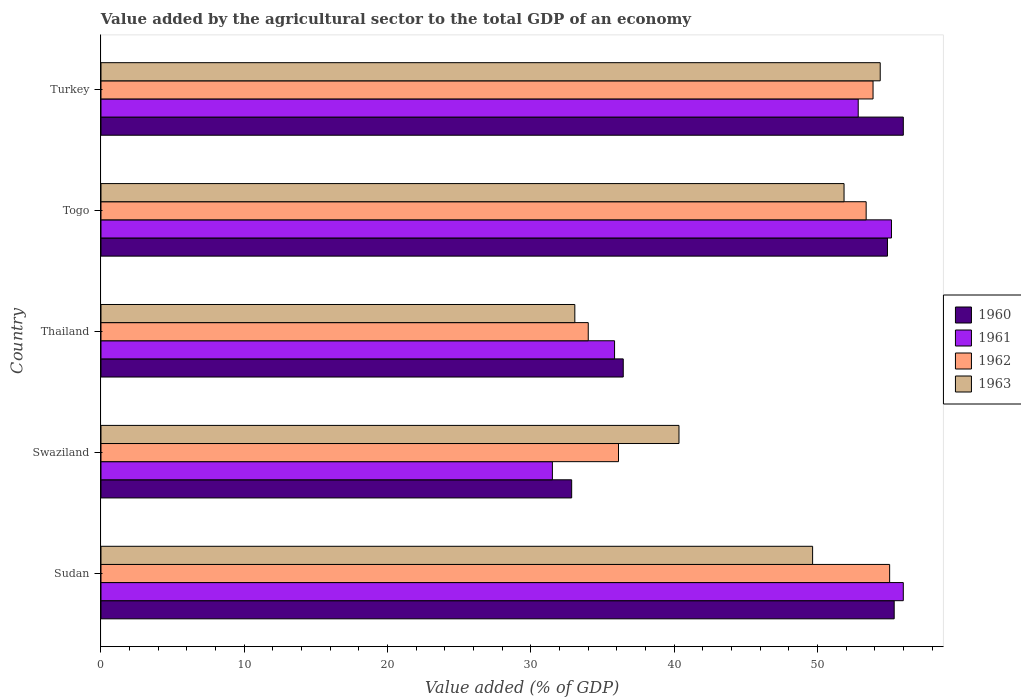How many different coloured bars are there?
Your answer should be compact. 4. How many bars are there on the 1st tick from the top?
Make the answer very short. 4. What is the label of the 5th group of bars from the top?
Provide a succinct answer. Sudan. What is the value added by the agricultural sector to the total GDP in 1960 in Turkey?
Offer a very short reply. 55.99. Across all countries, what is the maximum value added by the agricultural sector to the total GDP in 1960?
Provide a succinct answer. 55.99. Across all countries, what is the minimum value added by the agricultural sector to the total GDP in 1960?
Make the answer very short. 32.84. In which country was the value added by the agricultural sector to the total GDP in 1960 maximum?
Give a very brief answer. Turkey. In which country was the value added by the agricultural sector to the total GDP in 1963 minimum?
Ensure brevity in your answer.  Thailand. What is the total value added by the agricultural sector to the total GDP in 1963 in the graph?
Your answer should be compact. 229.29. What is the difference between the value added by the agricultural sector to the total GDP in 1962 in Swaziland and that in Thailand?
Offer a very short reply. 2.11. What is the difference between the value added by the agricultural sector to the total GDP in 1962 in Swaziland and the value added by the agricultural sector to the total GDP in 1963 in Thailand?
Give a very brief answer. 3.05. What is the average value added by the agricultural sector to the total GDP in 1963 per country?
Offer a very short reply. 45.86. What is the difference between the value added by the agricultural sector to the total GDP in 1963 and value added by the agricultural sector to the total GDP in 1960 in Swaziland?
Ensure brevity in your answer.  7.49. In how many countries, is the value added by the agricultural sector to the total GDP in 1960 greater than 22 %?
Keep it short and to the point. 5. What is the ratio of the value added by the agricultural sector to the total GDP in 1960 in Sudan to that in Turkey?
Your response must be concise. 0.99. Is the value added by the agricultural sector to the total GDP in 1962 in Sudan less than that in Togo?
Make the answer very short. No. What is the difference between the highest and the second highest value added by the agricultural sector to the total GDP in 1962?
Your response must be concise. 1.16. What is the difference between the highest and the lowest value added by the agricultural sector to the total GDP in 1960?
Offer a very short reply. 23.14. In how many countries, is the value added by the agricultural sector to the total GDP in 1963 greater than the average value added by the agricultural sector to the total GDP in 1963 taken over all countries?
Your answer should be very brief. 3. Is the sum of the value added by the agricultural sector to the total GDP in 1960 in Swaziland and Togo greater than the maximum value added by the agricultural sector to the total GDP in 1962 across all countries?
Your response must be concise. Yes. Is it the case that in every country, the sum of the value added by the agricultural sector to the total GDP in 1961 and value added by the agricultural sector to the total GDP in 1963 is greater than the sum of value added by the agricultural sector to the total GDP in 1962 and value added by the agricultural sector to the total GDP in 1960?
Provide a short and direct response. No. What does the 3rd bar from the top in Sudan represents?
Provide a short and direct response. 1961. Is it the case that in every country, the sum of the value added by the agricultural sector to the total GDP in 1960 and value added by the agricultural sector to the total GDP in 1962 is greater than the value added by the agricultural sector to the total GDP in 1963?
Offer a very short reply. Yes. Are all the bars in the graph horizontal?
Offer a terse response. Yes. What is the difference between two consecutive major ticks on the X-axis?
Give a very brief answer. 10. Does the graph contain any zero values?
Provide a succinct answer. No. Where does the legend appear in the graph?
Your answer should be compact. Center right. How many legend labels are there?
Provide a short and direct response. 4. What is the title of the graph?
Give a very brief answer. Value added by the agricultural sector to the total GDP of an economy. Does "1997" appear as one of the legend labels in the graph?
Your answer should be compact. No. What is the label or title of the X-axis?
Offer a very short reply. Value added (% of GDP). What is the Value added (% of GDP) of 1960 in Sudan?
Make the answer very short. 55.35. What is the Value added (% of GDP) of 1961 in Sudan?
Offer a very short reply. 55.99. What is the Value added (% of GDP) of 1962 in Sudan?
Give a very brief answer. 55.03. What is the Value added (% of GDP) of 1963 in Sudan?
Provide a succinct answer. 49.66. What is the Value added (% of GDP) of 1960 in Swaziland?
Provide a short and direct response. 32.84. What is the Value added (% of GDP) of 1961 in Swaziland?
Provide a short and direct response. 31.5. What is the Value added (% of GDP) in 1962 in Swaziland?
Offer a terse response. 36.11. What is the Value added (% of GDP) in 1963 in Swaziland?
Provide a succinct answer. 40.33. What is the Value added (% of GDP) in 1960 in Thailand?
Offer a terse response. 36.44. What is the Value added (% of GDP) of 1961 in Thailand?
Provide a succinct answer. 35.84. What is the Value added (% of GDP) in 1962 in Thailand?
Offer a terse response. 34. What is the Value added (% of GDP) in 1963 in Thailand?
Provide a succinct answer. 33.07. What is the Value added (% of GDP) in 1960 in Togo?
Ensure brevity in your answer.  54.88. What is the Value added (% of GDP) in 1961 in Togo?
Make the answer very short. 55.16. What is the Value added (% of GDP) in 1962 in Togo?
Ensure brevity in your answer.  53.4. What is the Value added (% of GDP) in 1963 in Togo?
Your answer should be very brief. 51.85. What is the Value added (% of GDP) of 1960 in Turkey?
Make the answer very short. 55.99. What is the Value added (% of GDP) of 1961 in Turkey?
Your response must be concise. 52.84. What is the Value added (% of GDP) in 1962 in Turkey?
Offer a very short reply. 53.88. What is the Value added (% of GDP) of 1963 in Turkey?
Ensure brevity in your answer.  54.38. Across all countries, what is the maximum Value added (% of GDP) of 1960?
Offer a terse response. 55.99. Across all countries, what is the maximum Value added (% of GDP) of 1961?
Your answer should be very brief. 55.99. Across all countries, what is the maximum Value added (% of GDP) of 1962?
Offer a very short reply. 55.03. Across all countries, what is the maximum Value added (% of GDP) in 1963?
Provide a succinct answer. 54.38. Across all countries, what is the minimum Value added (% of GDP) in 1960?
Provide a short and direct response. 32.84. Across all countries, what is the minimum Value added (% of GDP) in 1961?
Your answer should be very brief. 31.5. Across all countries, what is the minimum Value added (% of GDP) of 1962?
Ensure brevity in your answer.  34. Across all countries, what is the minimum Value added (% of GDP) of 1963?
Your response must be concise. 33.07. What is the total Value added (% of GDP) in 1960 in the graph?
Make the answer very short. 235.51. What is the total Value added (% of GDP) of 1961 in the graph?
Give a very brief answer. 231.33. What is the total Value added (% of GDP) in 1962 in the graph?
Ensure brevity in your answer.  232.42. What is the total Value added (% of GDP) in 1963 in the graph?
Your answer should be compact. 229.29. What is the difference between the Value added (% of GDP) in 1960 in Sudan and that in Swaziland?
Your answer should be compact. 22.51. What is the difference between the Value added (% of GDP) in 1961 in Sudan and that in Swaziland?
Keep it short and to the point. 24.49. What is the difference between the Value added (% of GDP) in 1962 in Sudan and that in Swaziland?
Keep it short and to the point. 18.92. What is the difference between the Value added (% of GDP) of 1963 in Sudan and that in Swaziland?
Ensure brevity in your answer.  9.32. What is the difference between the Value added (% of GDP) of 1960 in Sudan and that in Thailand?
Provide a short and direct response. 18.91. What is the difference between the Value added (% of GDP) in 1961 in Sudan and that in Thailand?
Provide a short and direct response. 20.15. What is the difference between the Value added (% of GDP) of 1962 in Sudan and that in Thailand?
Offer a very short reply. 21.03. What is the difference between the Value added (% of GDP) of 1963 in Sudan and that in Thailand?
Make the answer very short. 16.59. What is the difference between the Value added (% of GDP) of 1960 in Sudan and that in Togo?
Provide a succinct answer. 0.47. What is the difference between the Value added (% of GDP) in 1961 in Sudan and that in Togo?
Your answer should be compact. 0.83. What is the difference between the Value added (% of GDP) in 1962 in Sudan and that in Togo?
Your answer should be very brief. 1.64. What is the difference between the Value added (% of GDP) of 1963 in Sudan and that in Togo?
Make the answer very short. -2.19. What is the difference between the Value added (% of GDP) in 1960 in Sudan and that in Turkey?
Keep it short and to the point. -0.64. What is the difference between the Value added (% of GDP) in 1961 in Sudan and that in Turkey?
Your answer should be compact. 3.15. What is the difference between the Value added (% of GDP) of 1962 in Sudan and that in Turkey?
Provide a succinct answer. 1.16. What is the difference between the Value added (% of GDP) of 1963 in Sudan and that in Turkey?
Your response must be concise. -4.72. What is the difference between the Value added (% of GDP) of 1960 in Swaziland and that in Thailand?
Offer a very short reply. -3.6. What is the difference between the Value added (% of GDP) in 1961 in Swaziland and that in Thailand?
Give a very brief answer. -4.34. What is the difference between the Value added (% of GDP) in 1962 in Swaziland and that in Thailand?
Give a very brief answer. 2.11. What is the difference between the Value added (% of GDP) of 1963 in Swaziland and that in Thailand?
Give a very brief answer. 7.27. What is the difference between the Value added (% of GDP) of 1960 in Swaziland and that in Togo?
Keep it short and to the point. -22.04. What is the difference between the Value added (% of GDP) in 1961 in Swaziland and that in Togo?
Your answer should be very brief. -23.66. What is the difference between the Value added (% of GDP) in 1962 in Swaziland and that in Togo?
Ensure brevity in your answer.  -17.28. What is the difference between the Value added (% of GDP) of 1963 in Swaziland and that in Togo?
Make the answer very short. -11.52. What is the difference between the Value added (% of GDP) of 1960 in Swaziland and that in Turkey?
Keep it short and to the point. -23.14. What is the difference between the Value added (% of GDP) in 1961 in Swaziland and that in Turkey?
Your response must be concise. -21.34. What is the difference between the Value added (% of GDP) of 1962 in Swaziland and that in Turkey?
Ensure brevity in your answer.  -17.76. What is the difference between the Value added (% of GDP) of 1963 in Swaziland and that in Turkey?
Your answer should be compact. -14.04. What is the difference between the Value added (% of GDP) in 1960 in Thailand and that in Togo?
Make the answer very short. -18.44. What is the difference between the Value added (% of GDP) in 1961 in Thailand and that in Togo?
Your answer should be compact. -19.32. What is the difference between the Value added (% of GDP) in 1962 in Thailand and that in Togo?
Your answer should be compact. -19.39. What is the difference between the Value added (% of GDP) of 1963 in Thailand and that in Togo?
Your answer should be very brief. -18.79. What is the difference between the Value added (% of GDP) in 1960 in Thailand and that in Turkey?
Provide a succinct answer. -19.54. What is the difference between the Value added (% of GDP) in 1961 in Thailand and that in Turkey?
Make the answer very short. -17. What is the difference between the Value added (% of GDP) of 1962 in Thailand and that in Turkey?
Your response must be concise. -19.87. What is the difference between the Value added (% of GDP) in 1963 in Thailand and that in Turkey?
Offer a terse response. -21.31. What is the difference between the Value added (% of GDP) of 1960 in Togo and that in Turkey?
Keep it short and to the point. -1.11. What is the difference between the Value added (% of GDP) of 1961 in Togo and that in Turkey?
Offer a terse response. 2.32. What is the difference between the Value added (% of GDP) in 1962 in Togo and that in Turkey?
Give a very brief answer. -0.48. What is the difference between the Value added (% of GDP) in 1963 in Togo and that in Turkey?
Give a very brief answer. -2.52. What is the difference between the Value added (% of GDP) in 1960 in Sudan and the Value added (% of GDP) in 1961 in Swaziland?
Provide a succinct answer. 23.85. What is the difference between the Value added (% of GDP) of 1960 in Sudan and the Value added (% of GDP) of 1962 in Swaziland?
Ensure brevity in your answer.  19.24. What is the difference between the Value added (% of GDP) of 1960 in Sudan and the Value added (% of GDP) of 1963 in Swaziland?
Give a very brief answer. 15.02. What is the difference between the Value added (% of GDP) of 1961 in Sudan and the Value added (% of GDP) of 1962 in Swaziland?
Ensure brevity in your answer.  19.87. What is the difference between the Value added (% of GDP) in 1961 in Sudan and the Value added (% of GDP) in 1963 in Swaziland?
Provide a short and direct response. 15.65. What is the difference between the Value added (% of GDP) of 1962 in Sudan and the Value added (% of GDP) of 1963 in Swaziland?
Keep it short and to the point. 14.7. What is the difference between the Value added (% of GDP) of 1960 in Sudan and the Value added (% of GDP) of 1961 in Thailand?
Keep it short and to the point. 19.51. What is the difference between the Value added (% of GDP) in 1960 in Sudan and the Value added (% of GDP) in 1962 in Thailand?
Ensure brevity in your answer.  21.35. What is the difference between the Value added (% of GDP) of 1960 in Sudan and the Value added (% of GDP) of 1963 in Thailand?
Your answer should be very brief. 22.29. What is the difference between the Value added (% of GDP) in 1961 in Sudan and the Value added (% of GDP) in 1962 in Thailand?
Your response must be concise. 21.98. What is the difference between the Value added (% of GDP) of 1961 in Sudan and the Value added (% of GDP) of 1963 in Thailand?
Make the answer very short. 22.92. What is the difference between the Value added (% of GDP) in 1962 in Sudan and the Value added (% of GDP) in 1963 in Thailand?
Your answer should be compact. 21.97. What is the difference between the Value added (% of GDP) of 1960 in Sudan and the Value added (% of GDP) of 1961 in Togo?
Your response must be concise. 0.19. What is the difference between the Value added (% of GDP) of 1960 in Sudan and the Value added (% of GDP) of 1962 in Togo?
Offer a very short reply. 1.96. What is the difference between the Value added (% of GDP) of 1960 in Sudan and the Value added (% of GDP) of 1963 in Togo?
Give a very brief answer. 3.5. What is the difference between the Value added (% of GDP) in 1961 in Sudan and the Value added (% of GDP) in 1962 in Togo?
Provide a short and direct response. 2.59. What is the difference between the Value added (% of GDP) in 1961 in Sudan and the Value added (% of GDP) in 1963 in Togo?
Give a very brief answer. 4.13. What is the difference between the Value added (% of GDP) in 1962 in Sudan and the Value added (% of GDP) in 1963 in Togo?
Offer a very short reply. 3.18. What is the difference between the Value added (% of GDP) of 1960 in Sudan and the Value added (% of GDP) of 1961 in Turkey?
Your answer should be very brief. 2.51. What is the difference between the Value added (% of GDP) in 1960 in Sudan and the Value added (% of GDP) in 1962 in Turkey?
Ensure brevity in your answer.  1.48. What is the difference between the Value added (% of GDP) in 1960 in Sudan and the Value added (% of GDP) in 1963 in Turkey?
Give a very brief answer. 0.97. What is the difference between the Value added (% of GDP) in 1961 in Sudan and the Value added (% of GDP) in 1962 in Turkey?
Make the answer very short. 2.11. What is the difference between the Value added (% of GDP) in 1961 in Sudan and the Value added (% of GDP) in 1963 in Turkey?
Your response must be concise. 1.61. What is the difference between the Value added (% of GDP) of 1962 in Sudan and the Value added (% of GDP) of 1963 in Turkey?
Give a very brief answer. 0.66. What is the difference between the Value added (% of GDP) of 1960 in Swaziland and the Value added (% of GDP) of 1961 in Thailand?
Provide a short and direct response. -2.99. What is the difference between the Value added (% of GDP) of 1960 in Swaziland and the Value added (% of GDP) of 1962 in Thailand?
Keep it short and to the point. -1.16. What is the difference between the Value added (% of GDP) in 1960 in Swaziland and the Value added (% of GDP) in 1963 in Thailand?
Your response must be concise. -0.22. What is the difference between the Value added (% of GDP) in 1961 in Swaziland and the Value added (% of GDP) in 1962 in Thailand?
Offer a very short reply. -2.5. What is the difference between the Value added (% of GDP) of 1961 in Swaziland and the Value added (% of GDP) of 1963 in Thailand?
Ensure brevity in your answer.  -1.57. What is the difference between the Value added (% of GDP) of 1962 in Swaziland and the Value added (% of GDP) of 1963 in Thailand?
Your answer should be very brief. 3.05. What is the difference between the Value added (% of GDP) of 1960 in Swaziland and the Value added (% of GDP) of 1961 in Togo?
Your response must be concise. -22.32. What is the difference between the Value added (% of GDP) of 1960 in Swaziland and the Value added (% of GDP) of 1962 in Togo?
Offer a terse response. -20.55. What is the difference between the Value added (% of GDP) in 1960 in Swaziland and the Value added (% of GDP) in 1963 in Togo?
Provide a short and direct response. -19.01. What is the difference between the Value added (% of GDP) of 1961 in Swaziland and the Value added (% of GDP) of 1962 in Togo?
Offer a terse response. -21.9. What is the difference between the Value added (% of GDP) in 1961 in Swaziland and the Value added (% of GDP) in 1963 in Togo?
Provide a succinct answer. -20.35. What is the difference between the Value added (% of GDP) of 1962 in Swaziland and the Value added (% of GDP) of 1963 in Togo?
Offer a terse response. -15.74. What is the difference between the Value added (% of GDP) in 1960 in Swaziland and the Value added (% of GDP) in 1961 in Turkey?
Your response must be concise. -20. What is the difference between the Value added (% of GDP) of 1960 in Swaziland and the Value added (% of GDP) of 1962 in Turkey?
Your answer should be very brief. -21.03. What is the difference between the Value added (% of GDP) of 1960 in Swaziland and the Value added (% of GDP) of 1963 in Turkey?
Provide a succinct answer. -21.53. What is the difference between the Value added (% of GDP) of 1961 in Swaziland and the Value added (% of GDP) of 1962 in Turkey?
Keep it short and to the point. -22.38. What is the difference between the Value added (% of GDP) of 1961 in Swaziland and the Value added (% of GDP) of 1963 in Turkey?
Your answer should be very brief. -22.88. What is the difference between the Value added (% of GDP) of 1962 in Swaziland and the Value added (% of GDP) of 1963 in Turkey?
Make the answer very short. -18.26. What is the difference between the Value added (% of GDP) in 1960 in Thailand and the Value added (% of GDP) in 1961 in Togo?
Offer a very short reply. -18.72. What is the difference between the Value added (% of GDP) in 1960 in Thailand and the Value added (% of GDP) in 1962 in Togo?
Offer a very short reply. -16.95. What is the difference between the Value added (% of GDP) of 1960 in Thailand and the Value added (% of GDP) of 1963 in Togo?
Offer a terse response. -15.41. What is the difference between the Value added (% of GDP) of 1961 in Thailand and the Value added (% of GDP) of 1962 in Togo?
Offer a very short reply. -17.56. What is the difference between the Value added (% of GDP) in 1961 in Thailand and the Value added (% of GDP) in 1963 in Togo?
Give a very brief answer. -16.01. What is the difference between the Value added (% of GDP) in 1962 in Thailand and the Value added (% of GDP) in 1963 in Togo?
Make the answer very short. -17.85. What is the difference between the Value added (% of GDP) of 1960 in Thailand and the Value added (% of GDP) of 1961 in Turkey?
Your answer should be compact. -16.4. What is the difference between the Value added (% of GDP) in 1960 in Thailand and the Value added (% of GDP) in 1962 in Turkey?
Ensure brevity in your answer.  -17.43. What is the difference between the Value added (% of GDP) of 1960 in Thailand and the Value added (% of GDP) of 1963 in Turkey?
Provide a short and direct response. -17.93. What is the difference between the Value added (% of GDP) of 1961 in Thailand and the Value added (% of GDP) of 1962 in Turkey?
Ensure brevity in your answer.  -18.04. What is the difference between the Value added (% of GDP) of 1961 in Thailand and the Value added (% of GDP) of 1963 in Turkey?
Keep it short and to the point. -18.54. What is the difference between the Value added (% of GDP) of 1962 in Thailand and the Value added (% of GDP) of 1963 in Turkey?
Offer a terse response. -20.37. What is the difference between the Value added (% of GDP) in 1960 in Togo and the Value added (% of GDP) in 1961 in Turkey?
Give a very brief answer. 2.04. What is the difference between the Value added (% of GDP) in 1960 in Togo and the Value added (% of GDP) in 1962 in Turkey?
Offer a very short reply. 1.01. What is the difference between the Value added (% of GDP) in 1960 in Togo and the Value added (% of GDP) in 1963 in Turkey?
Provide a succinct answer. 0.51. What is the difference between the Value added (% of GDP) in 1961 in Togo and the Value added (% of GDP) in 1962 in Turkey?
Offer a very short reply. 1.29. What is the difference between the Value added (% of GDP) in 1961 in Togo and the Value added (% of GDP) in 1963 in Turkey?
Ensure brevity in your answer.  0.78. What is the difference between the Value added (% of GDP) of 1962 in Togo and the Value added (% of GDP) of 1963 in Turkey?
Offer a terse response. -0.98. What is the average Value added (% of GDP) in 1960 per country?
Offer a terse response. 47.1. What is the average Value added (% of GDP) of 1961 per country?
Provide a succinct answer. 46.27. What is the average Value added (% of GDP) in 1962 per country?
Provide a succinct answer. 46.48. What is the average Value added (% of GDP) of 1963 per country?
Provide a succinct answer. 45.86. What is the difference between the Value added (% of GDP) of 1960 and Value added (% of GDP) of 1961 in Sudan?
Your answer should be very brief. -0.64. What is the difference between the Value added (% of GDP) in 1960 and Value added (% of GDP) in 1962 in Sudan?
Offer a terse response. 0.32. What is the difference between the Value added (% of GDP) of 1960 and Value added (% of GDP) of 1963 in Sudan?
Keep it short and to the point. 5.69. What is the difference between the Value added (% of GDP) in 1961 and Value added (% of GDP) in 1962 in Sudan?
Ensure brevity in your answer.  0.95. What is the difference between the Value added (% of GDP) in 1961 and Value added (% of GDP) in 1963 in Sudan?
Ensure brevity in your answer.  6.33. What is the difference between the Value added (% of GDP) in 1962 and Value added (% of GDP) in 1963 in Sudan?
Offer a terse response. 5.37. What is the difference between the Value added (% of GDP) in 1960 and Value added (% of GDP) in 1961 in Swaziland?
Your answer should be compact. 1.35. What is the difference between the Value added (% of GDP) in 1960 and Value added (% of GDP) in 1962 in Swaziland?
Your answer should be very brief. -3.27. What is the difference between the Value added (% of GDP) in 1960 and Value added (% of GDP) in 1963 in Swaziland?
Make the answer very short. -7.49. What is the difference between the Value added (% of GDP) of 1961 and Value added (% of GDP) of 1962 in Swaziland?
Your response must be concise. -4.61. What is the difference between the Value added (% of GDP) of 1961 and Value added (% of GDP) of 1963 in Swaziland?
Ensure brevity in your answer.  -8.83. What is the difference between the Value added (% of GDP) of 1962 and Value added (% of GDP) of 1963 in Swaziland?
Give a very brief answer. -4.22. What is the difference between the Value added (% of GDP) in 1960 and Value added (% of GDP) in 1961 in Thailand?
Offer a very short reply. 0.61. What is the difference between the Value added (% of GDP) of 1960 and Value added (% of GDP) of 1962 in Thailand?
Provide a succinct answer. 2.44. What is the difference between the Value added (% of GDP) in 1960 and Value added (% of GDP) in 1963 in Thailand?
Your answer should be compact. 3.38. What is the difference between the Value added (% of GDP) of 1961 and Value added (% of GDP) of 1962 in Thailand?
Your answer should be very brief. 1.84. What is the difference between the Value added (% of GDP) in 1961 and Value added (% of GDP) in 1963 in Thailand?
Ensure brevity in your answer.  2.77. What is the difference between the Value added (% of GDP) of 1962 and Value added (% of GDP) of 1963 in Thailand?
Make the answer very short. 0.94. What is the difference between the Value added (% of GDP) in 1960 and Value added (% of GDP) in 1961 in Togo?
Your answer should be compact. -0.28. What is the difference between the Value added (% of GDP) in 1960 and Value added (% of GDP) in 1962 in Togo?
Your answer should be very brief. 1.49. What is the difference between the Value added (% of GDP) of 1960 and Value added (% of GDP) of 1963 in Togo?
Provide a succinct answer. 3.03. What is the difference between the Value added (% of GDP) of 1961 and Value added (% of GDP) of 1962 in Togo?
Your answer should be compact. 1.77. What is the difference between the Value added (% of GDP) in 1961 and Value added (% of GDP) in 1963 in Togo?
Make the answer very short. 3.31. What is the difference between the Value added (% of GDP) of 1962 and Value added (% of GDP) of 1963 in Togo?
Make the answer very short. 1.54. What is the difference between the Value added (% of GDP) in 1960 and Value added (% of GDP) in 1961 in Turkey?
Provide a succinct answer. 3.15. What is the difference between the Value added (% of GDP) in 1960 and Value added (% of GDP) in 1962 in Turkey?
Your response must be concise. 2.11. What is the difference between the Value added (% of GDP) in 1960 and Value added (% of GDP) in 1963 in Turkey?
Your answer should be very brief. 1.61. What is the difference between the Value added (% of GDP) of 1961 and Value added (% of GDP) of 1962 in Turkey?
Your answer should be very brief. -1.03. What is the difference between the Value added (% of GDP) in 1961 and Value added (% of GDP) in 1963 in Turkey?
Keep it short and to the point. -1.54. What is the difference between the Value added (% of GDP) of 1962 and Value added (% of GDP) of 1963 in Turkey?
Your response must be concise. -0.5. What is the ratio of the Value added (% of GDP) of 1960 in Sudan to that in Swaziland?
Ensure brevity in your answer.  1.69. What is the ratio of the Value added (% of GDP) in 1961 in Sudan to that in Swaziland?
Give a very brief answer. 1.78. What is the ratio of the Value added (% of GDP) of 1962 in Sudan to that in Swaziland?
Offer a very short reply. 1.52. What is the ratio of the Value added (% of GDP) of 1963 in Sudan to that in Swaziland?
Offer a terse response. 1.23. What is the ratio of the Value added (% of GDP) in 1960 in Sudan to that in Thailand?
Your response must be concise. 1.52. What is the ratio of the Value added (% of GDP) of 1961 in Sudan to that in Thailand?
Your response must be concise. 1.56. What is the ratio of the Value added (% of GDP) in 1962 in Sudan to that in Thailand?
Provide a succinct answer. 1.62. What is the ratio of the Value added (% of GDP) of 1963 in Sudan to that in Thailand?
Your answer should be very brief. 1.5. What is the ratio of the Value added (% of GDP) in 1960 in Sudan to that in Togo?
Offer a very short reply. 1.01. What is the ratio of the Value added (% of GDP) of 1962 in Sudan to that in Togo?
Ensure brevity in your answer.  1.03. What is the ratio of the Value added (% of GDP) in 1963 in Sudan to that in Togo?
Ensure brevity in your answer.  0.96. What is the ratio of the Value added (% of GDP) in 1961 in Sudan to that in Turkey?
Offer a very short reply. 1.06. What is the ratio of the Value added (% of GDP) of 1962 in Sudan to that in Turkey?
Provide a succinct answer. 1.02. What is the ratio of the Value added (% of GDP) of 1963 in Sudan to that in Turkey?
Your answer should be compact. 0.91. What is the ratio of the Value added (% of GDP) of 1960 in Swaziland to that in Thailand?
Offer a very short reply. 0.9. What is the ratio of the Value added (% of GDP) in 1961 in Swaziland to that in Thailand?
Give a very brief answer. 0.88. What is the ratio of the Value added (% of GDP) in 1962 in Swaziland to that in Thailand?
Ensure brevity in your answer.  1.06. What is the ratio of the Value added (% of GDP) of 1963 in Swaziland to that in Thailand?
Your response must be concise. 1.22. What is the ratio of the Value added (% of GDP) of 1960 in Swaziland to that in Togo?
Make the answer very short. 0.6. What is the ratio of the Value added (% of GDP) in 1961 in Swaziland to that in Togo?
Ensure brevity in your answer.  0.57. What is the ratio of the Value added (% of GDP) of 1962 in Swaziland to that in Togo?
Keep it short and to the point. 0.68. What is the ratio of the Value added (% of GDP) of 1963 in Swaziland to that in Togo?
Provide a succinct answer. 0.78. What is the ratio of the Value added (% of GDP) of 1960 in Swaziland to that in Turkey?
Provide a succinct answer. 0.59. What is the ratio of the Value added (% of GDP) in 1961 in Swaziland to that in Turkey?
Offer a very short reply. 0.6. What is the ratio of the Value added (% of GDP) of 1962 in Swaziland to that in Turkey?
Offer a terse response. 0.67. What is the ratio of the Value added (% of GDP) of 1963 in Swaziland to that in Turkey?
Your answer should be very brief. 0.74. What is the ratio of the Value added (% of GDP) in 1960 in Thailand to that in Togo?
Give a very brief answer. 0.66. What is the ratio of the Value added (% of GDP) of 1961 in Thailand to that in Togo?
Ensure brevity in your answer.  0.65. What is the ratio of the Value added (% of GDP) of 1962 in Thailand to that in Togo?
Offer a very short reply. 0.64. What is the ratio of the Value added (% of GDP) in 1963 in Thailand to that in Togo?
Your answer should be compact. 0.64. What is the ratio of the Value added (% of GDP) of 1960 in Thailand to that in Turkey?
Provide a short and direct response. 0.65. What is the ratio of the Value added (% of GDP) in 1961 in Thailand to that in Turkey?
Keep it short and to the point. 0.68. What is the ratio of the Value added (% of GDP) in 1962 in Thailand to that in Turkey?
Provide a succinct answer. 0.63. What is the ratio of the Value added (% of GDP) of 1963 in Thailand to that in Turkey?
Provide a short and direct response. 0.61. What is the ratio of the Value added (% of GDP) in 1960 in Togo to that in Turkey?
Give a very brief answer. 0.98. What is the ratio of the Value added (% of GDP) of 1961 in Togo to that in Turkey?
Ensure brevity in your answer.  1.04. What is the ratio of the Value added (% of GDP) of 1962 in Togo to that in Turkey?
Your answer should be very brief. 0.99. What is the ratio of the Value added (% of GDP) of 1963 in Togo to that in Turkey?
Your answer should be very brief. 0.95. What is the difference between the highest and the second highest Value added (% of GDP) of 1960?
Offer a terse response. 0.64. What is the difference between the highest and the second highest Value added (% of GDP) in 1961?
Provide a short and direct response. 0.83. What is the difference between the highest and the second highest Value added (% of GDP) in 1962?
Your answer should be compact. 1.16. What is the difference between the highest and the second highest Value added (% of GDP) of 1963?
Your answer should be very brief. 2.52. What is the difference between the highest and the lowest Value added (% of GDP) of 1960?
Offer a terse response. 23.14. What is the difference between the highest and the lowest Value added (% of GDP) of 1961?
Offer a very short reply. 24.49. What is the difference between the highest and the lowest Value added (% of GDP) in 1962?
Your answer should be compact. 21.03. What is the difference between the highest and the lowest Value added (% of GDP) in 1963?
Provide a succinct answer. 21.31. 